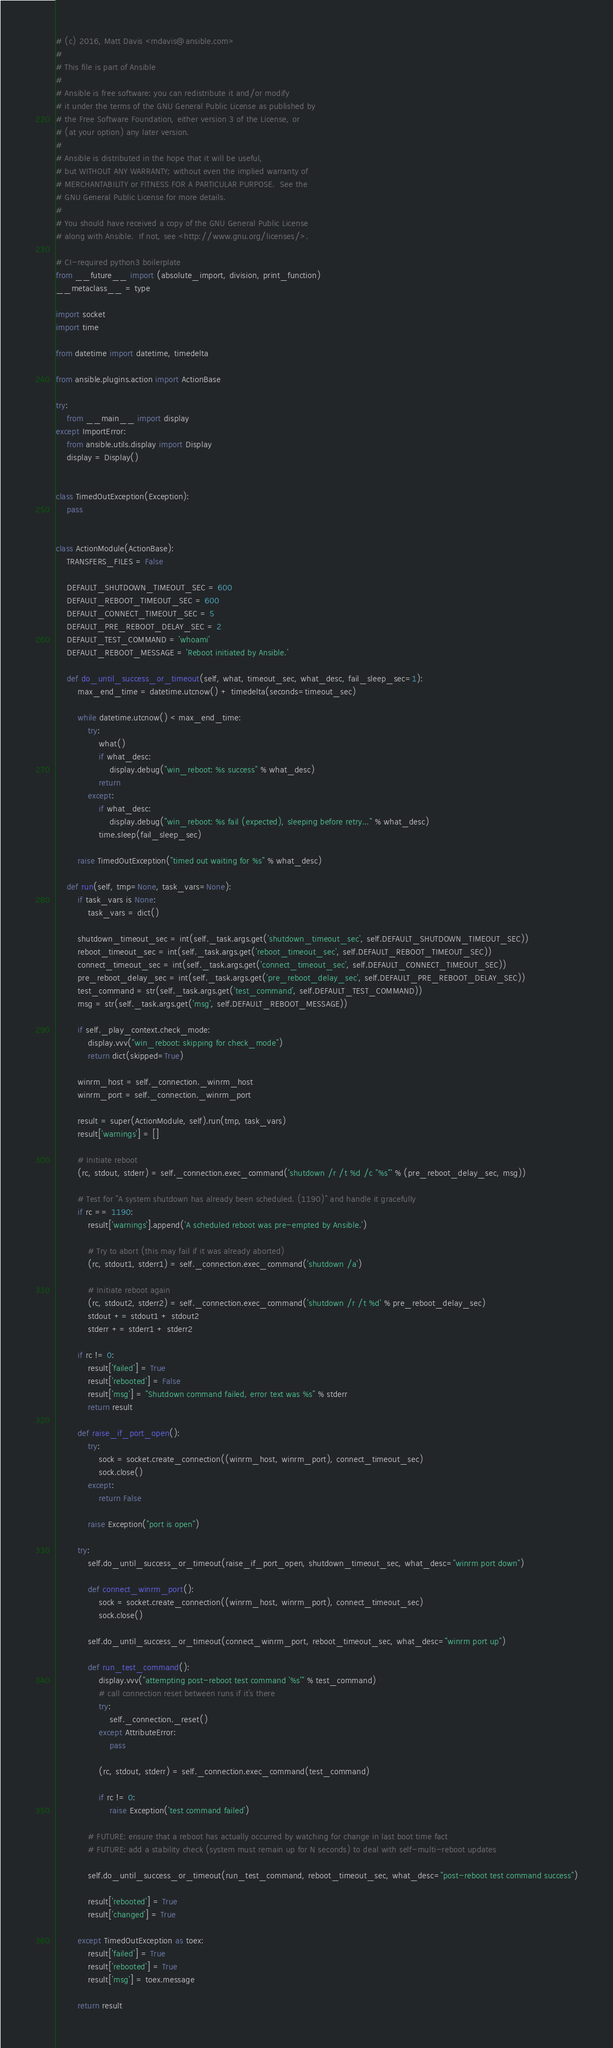Convert code to text. <code><loc_0><loc_0><loc_500><loc_500><_Python_># (c) 2016, Matt Davis <mdavis@ansible.com>
#
# This file is part of Ansible
#
# Ansible is free software: you can redistribute it and/or modify
# it under the terms of the GNU General Public License as published by
# the Free Software Foundation, either version 3 of the License, or
# (at your option) any later version.
#
# Ansible is distributed in the hope that it will be useful,
# but WITHOUT ANY WARRANTY; without even the implied warranty of
# MERCHANTABILITY or FITNESS FOR A PARTICULAR PURPOSE.  See the
# GNU General Public License for more details.
#
# You should have received a copy of the GNU General Public License
# along with Ansible.  If not, see <http://www.gnu.org/licenses/>.

# CI-required python3 boilerplate
from __future__ import (absolute_import, division, print_function)
__metaclass__ = type

import socket
import time

from datetime import datetime, timedelta

from ansible.plugins.action import ActionBase

try:
    from __main__ import display
except ImportError:
    from ansible.utils.display import Display
    display = Display()


class TimedOutException(Exception):
    pass


class ActionModule(ActionBase):
    TRANSFERS_FILES = False

    DEFAULT_SHUTDOWN_TIMEOUT_SEC = 600
    DEFAULT_REBOOT_TIMEOUT_SEC = 600
    DEFAULT_CONNECT_TIMEOUT_SEC = 5
    DEFAULT_PRE_REBOOT_DELAY_SEC = 2
    DEFAULT_TEST_COMMAND = 'whoami'
    DEFAULT_REBOOT_MESSAGE = 'Reboot initiated by Ansible.'

    def do_until_success_or_timeout(self, what, timeout_sec, what_desc, fail_sleep_sec=1):
        max_end_time = datetime.utcnow() + timedelta(seconds=timeout_sec)

        while datetime.utcnow() < max_end_time:
            try:
                what()
                if what_desc:
                    display.debug("win_reboot: %s success" % what_desc)
                return
            except:
                if what_desc:
                    display.debug("win_reboot: %s fail (expected), sleeping before retry..." % what_desc)
                time.sleep(fail_sleep_sec)

        raise TimedOutException("timed out waiting for %s" % what_desc)

    def run(self, tmp=None, task_vars=None):
        if task_vars is None:
            task_vars = dict()

        shutdown_timeout_sec = int(self._task.args.get('shutdown_timeout_sec', self.DEFAULT_SHUTDOWN_TIMEOUT_SEC))
        reboot_timeout_sec = int(self._task.args.get('reboot_timeout_sec', self.DEFAULT_REBOOT_TIMEOUT_SEC))
        connect_timeout_sec = int(self._task.args.get('connect_timeout_sec', self.DEFAULT_CONNECT_TIMEOUT_SEC))
        pre_reboot_delay_sec = int(self._task.args.get('pre_reboot_delay_sec', self.DEFAULT_PRE_REBOOT_DELAY_SEC))
        test_command = str(self._task.args.get('test_command', self.DEFAULT_TEST_COMMAND))
        msg = str(self._task.args.get('msg', self.DEFAULT_REBOOT_MESSAGE))

        if self._play_context.check_mode:
            display.vvv("win_reboot: skipping for check_mode")
            return dict(skipped=True)

        winrm_host = self._connection._winrm_host
        winrm_port = self._connection._winrm_port

        result = super(ActionModule, self).run(tmp, task_vars)
        result['warnings'] = []

        # Initiate reboot
        (rc, stdout, stderr) = self._connection.exec_command('shutdown /r /t %d /c "%s"' % (pre_reboot_delay_sec, msg))

        # Test for "A system shutdown has already been scheduled. (1190)" and handle it gracefully
        if rc == 1190:
            result['warnings'].append('A scheduled reboot was pre-empted by Ansible.')

            # Try to abort (this may fail if it was already aborted)
            (rc, stdout1, stderr1) = self._connection.exec_command('shutdown /a')

            # Initiate reboot again
            (rc, stdout2, stderr2) = self._connection.exec_command('shutdown /r /t %d' % pre_reboot_delay_sec)
            stdout += stdout1 + stdout2
            stderr += stderr1 + stderr2

        if rc != 0:
            result['failed'] = True
            result['rebooted'] = False
            result['msg'] = "Shutdown command failed, error text was %s" % stderr
            return result

        def raise_if_port_open():
            try:
                sock = socket.create_connection((winrm_host, winrm_port), connect_timeout_sec)
                sock.close()
            except:
                return False

            raise Exception("port is open")

        try:
            self.do_until_success_or_timeout(raise_if_port_open, shutdown_timeout_sec, what_desc="winrm port down")

            def connect_winrm_port():
                sock = socket.create_connection((winrm_host, winrm_port), connect_timeout_sec)
                sock.close()

            self.do_until_success_or_timeout(connect_winrm_port, reboot_timeout_sec, what_desc="winrm port up")

            def run_test_command():
                display.vvv("attempting post-reboot test command '%s'" % test_command)
                # call connection reset between runs if it's there
                try:
                    self._connection._reset()
                except AttributeError:
                    pass

                (rc, stdout, stderr) = self._connection.exec_command(test_command)

                if rc != 0:
                    raise Exception('test command failed')

            # FUTURE: ensure that a reboot has actually occurred by watching for change in last boot time fact
            # FUTURE: add a stability check (system must remain up for N seconds) to deal with self-multi-reboot updates

            self.do_until_success_or_timeout(run_test_command, reboot_timeout_sec, what_desc="post-reboot test command success")

            result['rebooted'] = True
            result['changed'] = True

        except TimedOutException as toex:
            result['failed'] = True
            result['rebooted'] = True
            result['msg'] = toex.message

        return result
</code> 